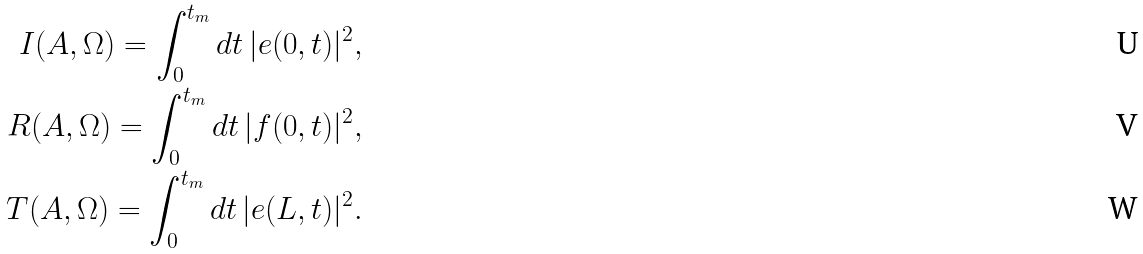<formula> <loc_0><loc_0><loc_500><loc_500>I ( A , \Omega ) = \int _ { 0 } ^ { t _ { m } } d t \, | e ( 0 , t ) | ^ { 2 } , \\ R ( A , \Omega ) = \int _ { 0 } ^ { t _ { m } } d t \, | f ( 0 , t ) | ^ { 2 } , \\ T ( A , \Omega ) = \int _ { 0 } ^ { t _ { m } } d t \, | e ( L , t ) | ^ { 2 } .</formula> 